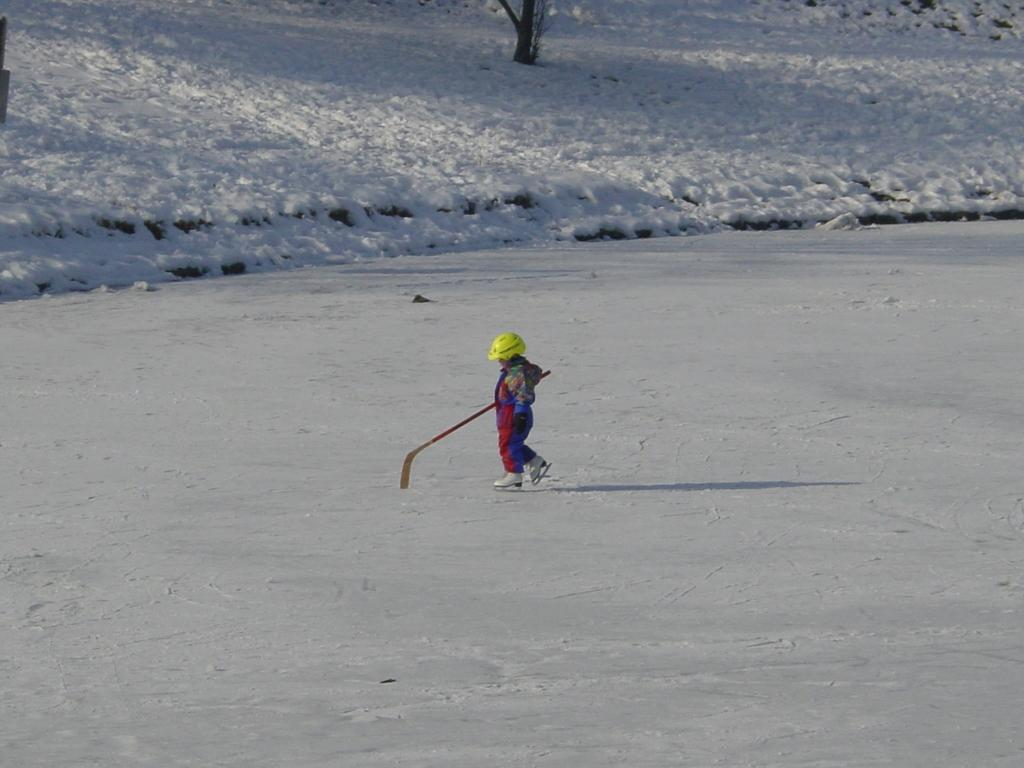What is the main subject of the image? The main subject of the image is a kid. Where is the kid located in the image? The kid is on the snow in the image. What protective gear is the kid wearing? The kid is wearing a helmet in the image. What object is the kid holding? The kid is holding a stick in the image. What can be seen in the background of the image? There is a tree in the background of the image. What type of canvas is visible in the image? There is no canvas present in the image. What type of clouds can be seen in the image? The image does not show any clouds; it is set on a snowy background. 